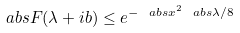Convert formula to latex. <formula><loc_0><loc_0><loc_500><loc_500>\ a b s { F ( \lambda + i b ) } \leq e ^ { - \ a b s { x } ^ { 2 } \ a b s { \lambda } / 8 }</formula> 